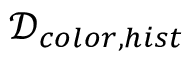<formula> <loc_0><loc_0><loc_500><loc_500>\mathcal { D } _ { { c o l o r } , { h i s t } }</formula> 